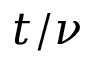<formula> <loc_0><loc_0><loc_500><loc_500>t / \nu</formula> 